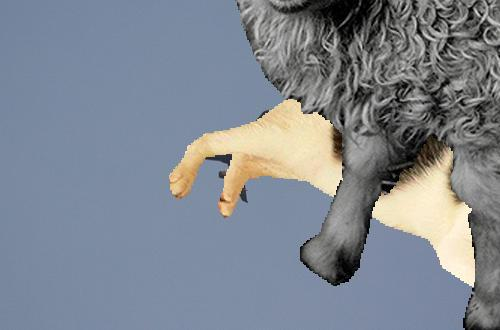Describe the artistic theme or concept behind this edited image. The image represents a playful fusion of human and animal traits, blending sheep's hooves with human-like hands, suggesting themes of hybridity and surrealism. It seems to explore the boundaries between the natural and the synthetic, inviting viewers to ponder the relationship and distinctions between humans and animals. 